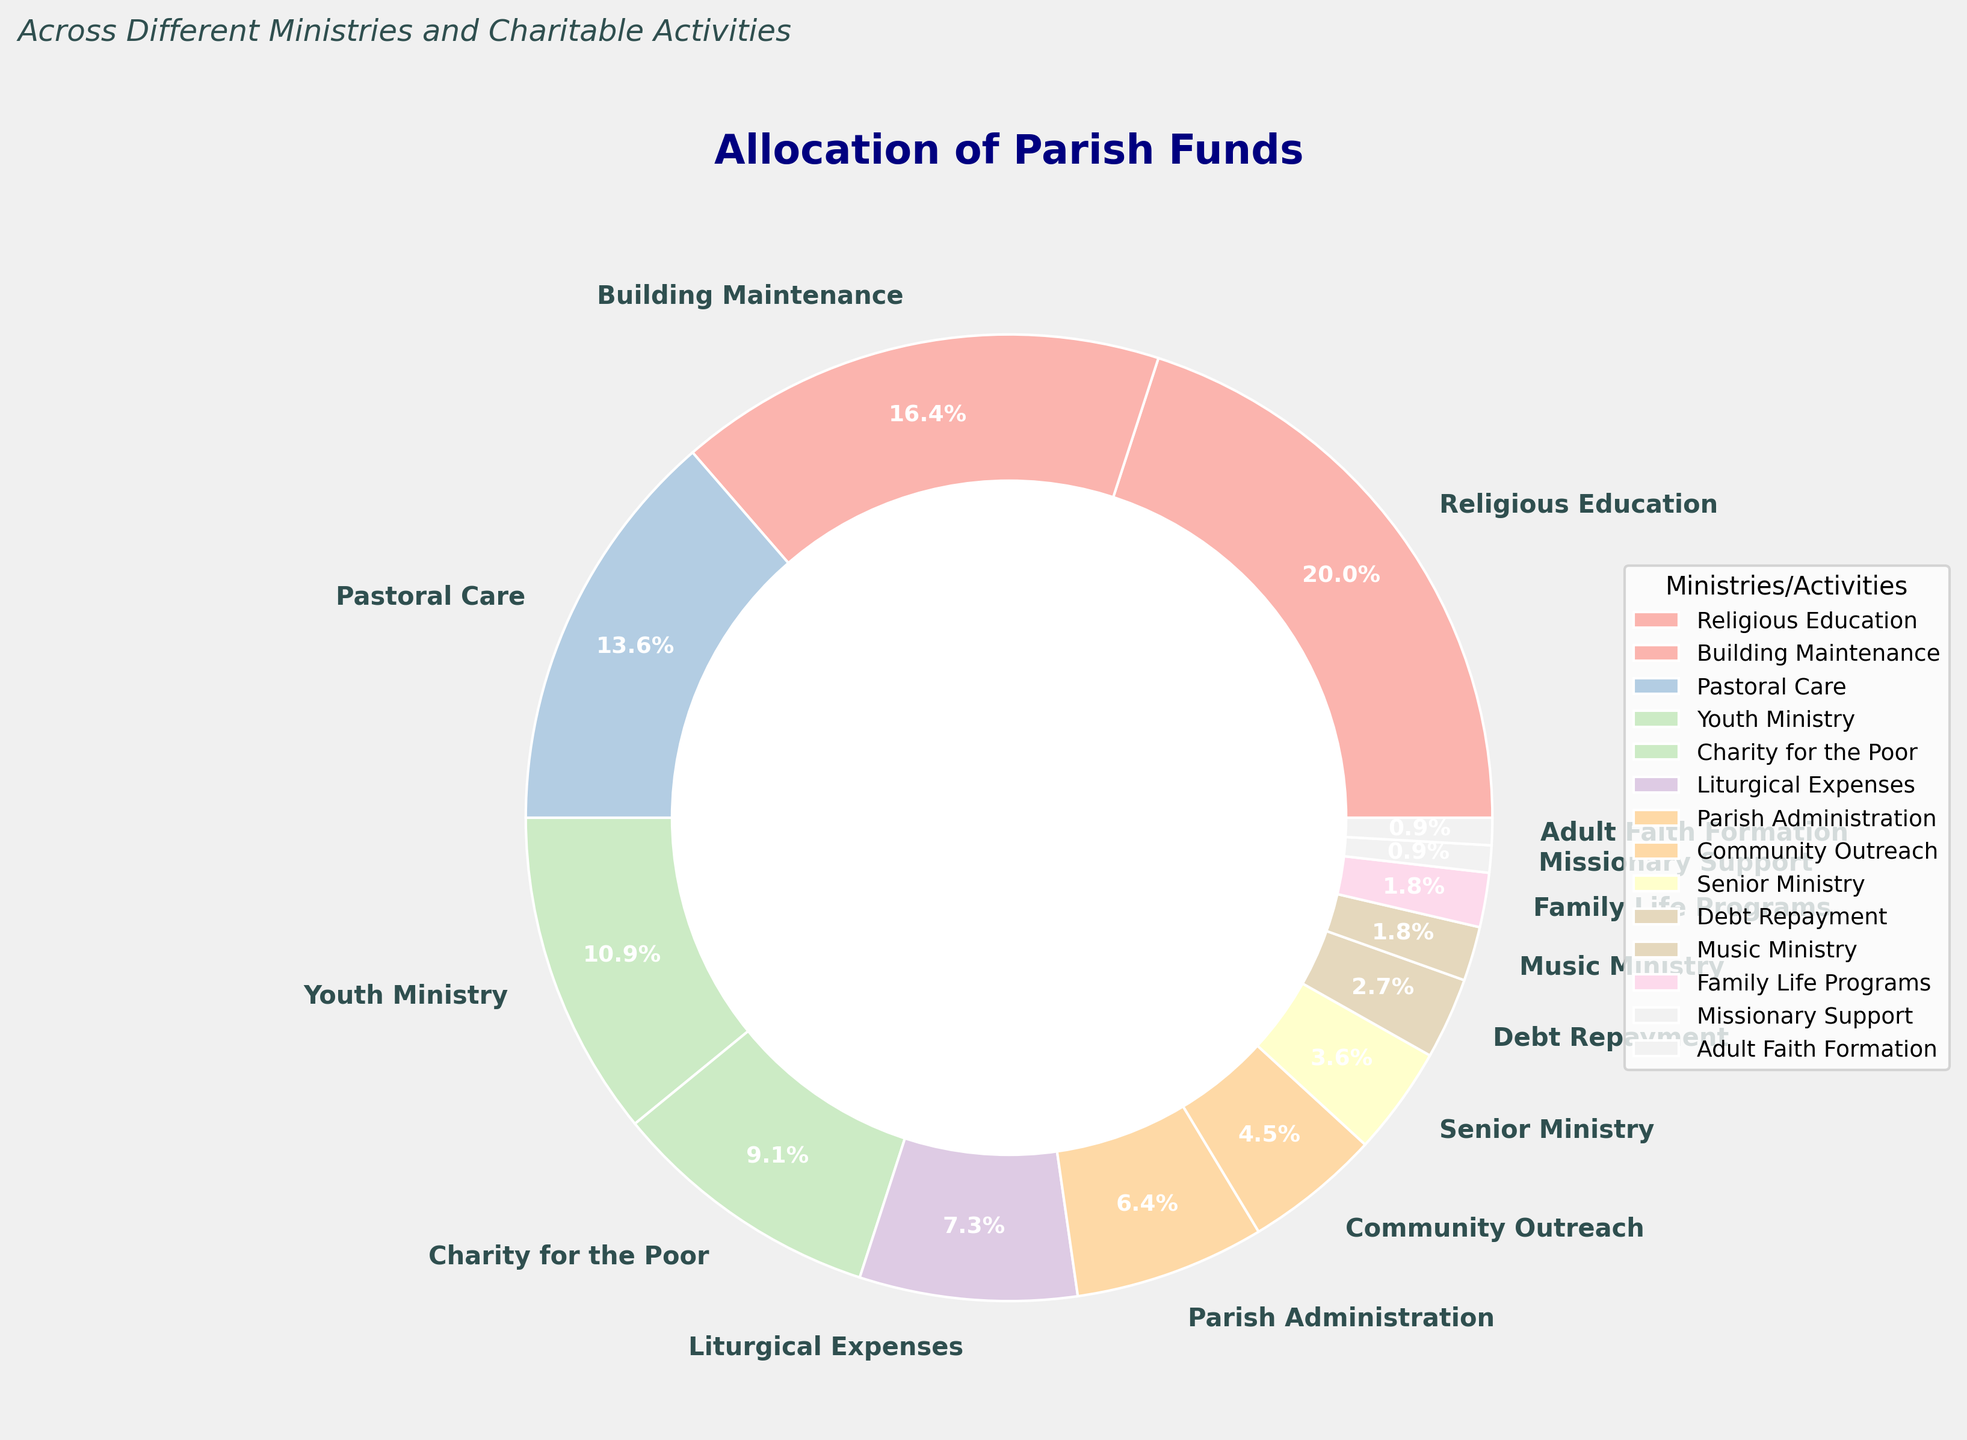What percentage of the parish funds is allocated to Youth Ministry and Pastoral Care combined? Youth Ministry is allocated 12%, and Pastoral Care is allocated 15%. Adding these percentages together, we get 12% + 15% = 27%.
Answer: 27% Which ministry receives a larger percentage of the parish funds, Building Maintenance or Liturgical Expenses? Building Maintenance is allocated 18%, and Liturgical Expenses receive 8%. Since 18% is greater than 8%, Building Maintenance receives a larger percentage.
Answer: Building Maintenance What is the visual difference in size between the slices for Charity for the Poor and Family Life Programs? Charity for the Poor is represented by a slice labeled 10%, and Family Life Programs have a slice labeled 2%. Visually, the slice for Charity for the Poor is significantly larger compared to Family Life Programs.
Answer: Charity for the Poor has a larger slice How much more funding is allocated to Religious Education compared to Debt Repayment? Religious Education is allocated 22%, and Debt Repayment is 3%. The difference in their percentages is 22% - 3% = 19%.
Answer: 19% Which three ministries or activities receive the smallest portions of the parish funds? The three ministries or activities with the smallest portions are Missionary Support (1%), Adult Faith Formation (1%), and Family Life Programs (2%).
Answer: Missionary Support, Adult Faith Formation, and Family Life Programs Which receives less funding: Community Outreach or Senior Ministry? Community Outreach is allocated 5%, whereas Senior Ministry receives 4%. Therefore, Senior Ministry receives less funding.
Answer: Senior Ministry What percentage of the parish funds is allocated to activities directly benefiting families (Family Life Programs and Adult Faith Formation)? Family Life Programs receive 2%, and Adult Faith Formation receives 1%. Adding these, we get 2% + 1% = 3%.
Answer: 3% If you were to combine the funds for Music Ministry and Missionary Support, what would be their combined total percentage? Music Ministry is allocated 2%, and Missionary Support is 1%. Their combined percentage is 2% + 1% = 3%.
Answer: 3% Which ministry or activity has the second-largest allocation of the parish funds, and what is that percentage? Building Maintenance has the second-largest allocation with 18%. The largest is Religious Education with 22%, making Building Maintenance second.
Answer: Building Maintenance, 18% What is the average percentage allocation of funds to all ministries and activities? Adding all the percentages of the 14 ministries and activities: 
22 + 18 + 15 + 12 + 10 + 8 + 7 + 5 + 4 + 3 + 2 + 2 + 1 + 1 = 110%. Dividing by the number of activities, 110% / 14 ≈ 7.86%.
Answer: 7.86% 